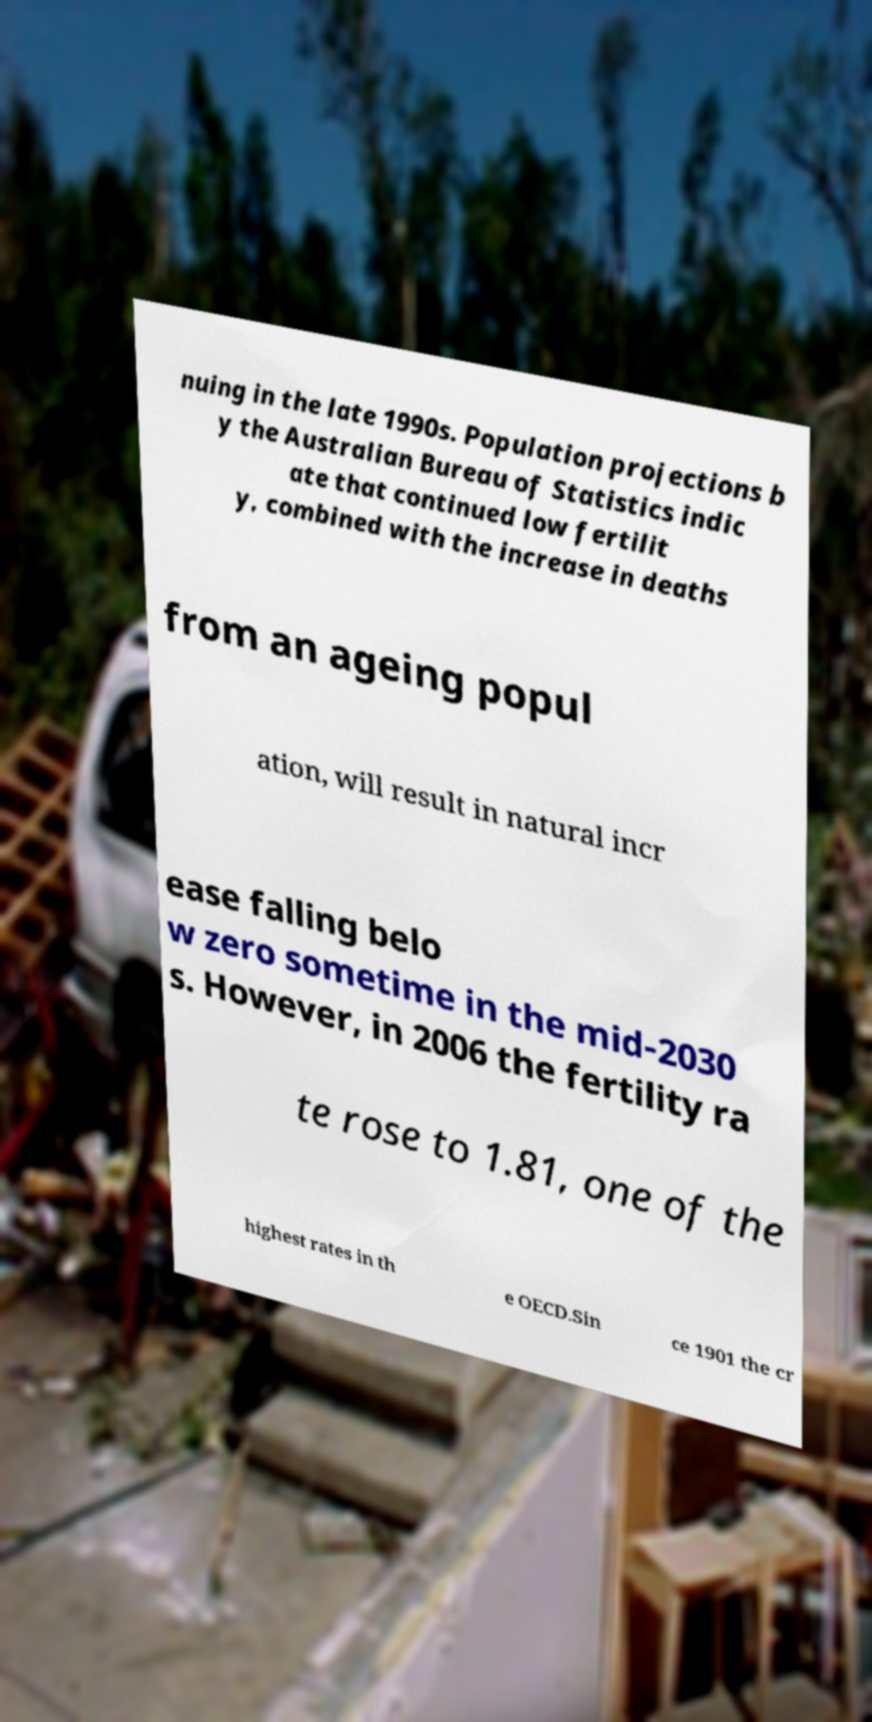Please read and relay the text visible in this image. What does it say? nuing in the late 1990s. Population projections b y the Australian Bureau of Statistics indic ate that continued low fertilit y, combined with the increase in deaths from an ageing popul ation, will result in natural incr ease falling belo w zero sometime in the mid-2030 s. However, in 2006 the fertility ra te rose to 1.81, one of the highest rates in th e OECD.Sin ce 1901 the cr 